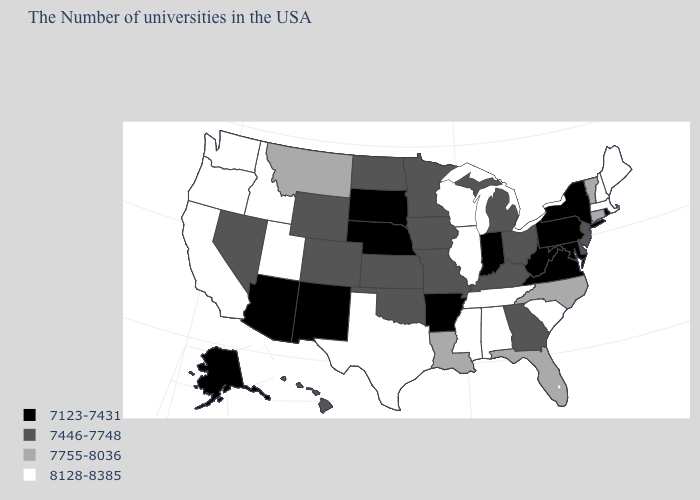Which states hav the highest value in the South?
Be succinct. South Carolina, Alabama, Tennessee, Mississippi, Texas. Does the first symbol in the legend represent the smallest category?
Quick response, please. Yes. What is the value of Rhode Island?
Write a very short answer. 7123-7431. Does the first symbol in the legend represent the smallest category?
Answer briefly. Yes. Does the first symbol in the legend represent the smallest category?
Answer briefly. Yes. Does the first symbol in the legend represent the smallest category?
Keep it brief. Yes. What is the value of California?
Short answer required. 8128-8385. What is the lowest value in states that border Montana?
Quick response, please. 7123-7431. Does Louisiana have a higher value than Wisconsin?
Give a very brief answer. No. Which states have the highest value in the USA?
Answer briefly. Maine, Massachusetts, New Hampshire, South Carolina, Alabama, Tennessee, Wisconsin, Illinois, Mississippi, Texas, Utah, Idaho, California, Washington, Oregon. Name the states that have a value in the range 7123-7431?
Concise answer only. Rhode Island, New York, Maryland, Pennsylvania, Virginia, West Virginia, Indiana, Arkansas, Nebraska, South Dakota, New Mexico, Arizona, Alaska. Among the states that border Oregon , does Nevada have the lowest value?
Be succinct. Yes. Among the states that border South Carolina , does North Carolina have the highest value?
Concise answer only. Yes. What is the value of Michigan?
Give a very brief answer. 7446-7748. Does Mississippi have the highest value in the USA?
Concise answer only. Yes. 